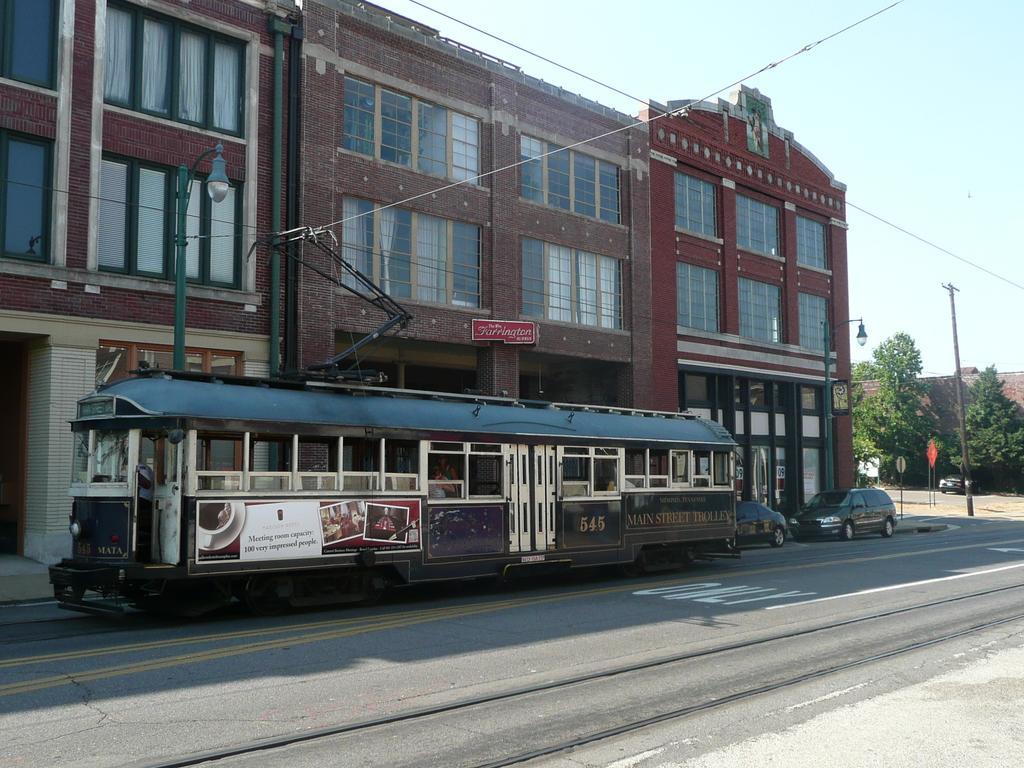How would you summarize this image in a sentence or two? There are vehicles on the road. On the right side, there is footpath. In the background, there is building which is having glass windows, there are trees, vehicles parked, houses, electrical lines and there is blue sky. 